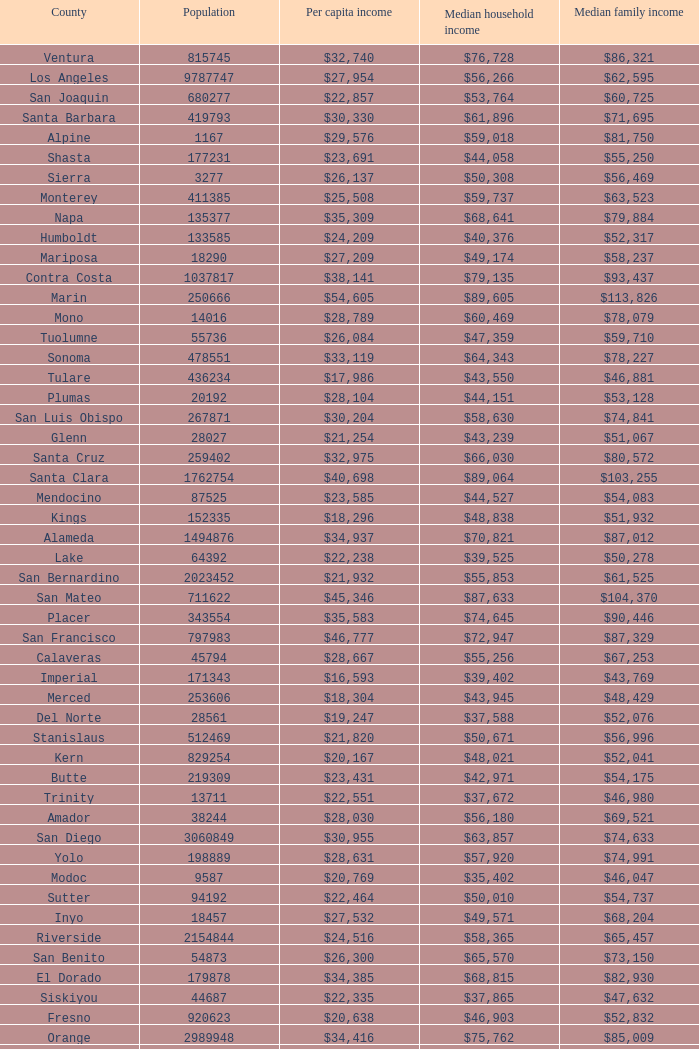Name the median family income for riverside $65,457. 